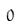<formula> <loc_0><loc_0><loc_500><loc_500>0</formula> 